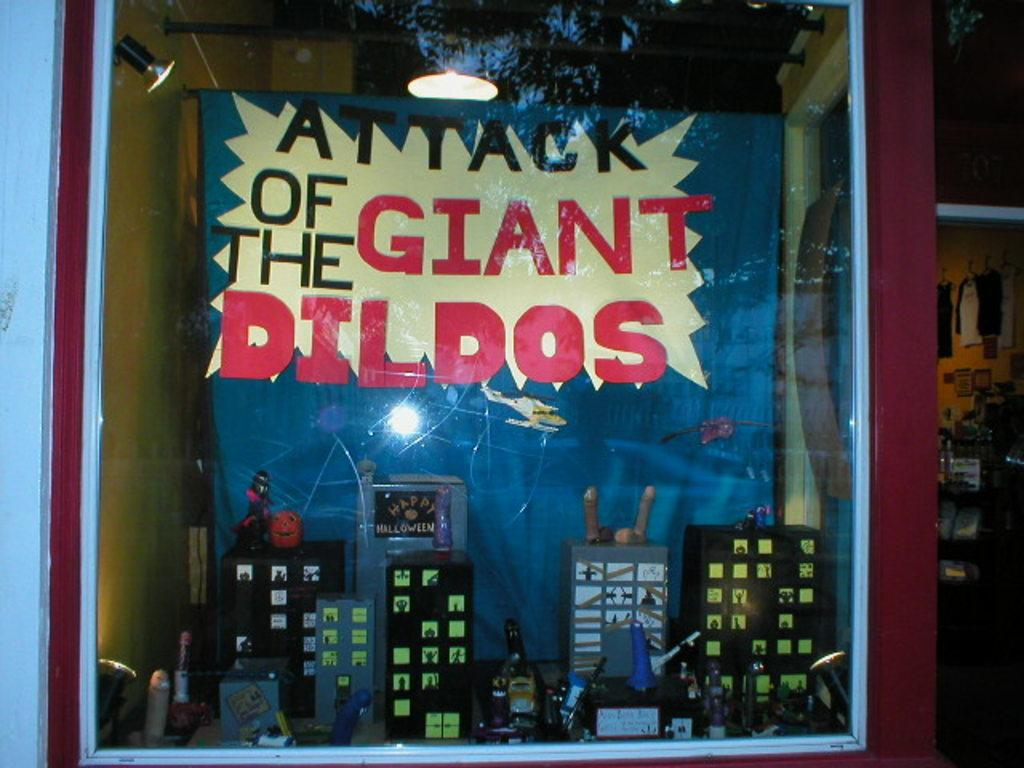<image>
Provide a brief description of the given image. A sign and display for attack of the giant with a few buildings beneath. 